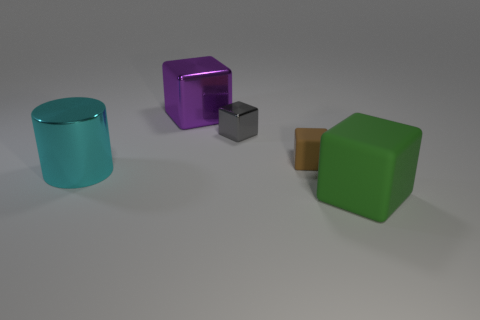Subtract all tiny brown matte cubes. How many cubes are left? 3 Add 3 small gray metallic objects. How many objects exist? 8 Subtract 1 blocks. How many blocks are left? 3 Subtract all purple blocks. How many blocks are left? 3 Subtract all cylinders. How many objects are left? 4 Add 4 large cyan rubber blocks. How many large cyan rubber blocks exist? 4 Subtract 0 cyan spheres. How many objects are left? 5 Subtract all red cylinders. Subtract all purple balls. How many cylinders are left? 1 Subtract all purple cubes. Subtract all cubes. How many objects are left? 0 Add 5 tiny rubber cubes. How many tiny rubber cubes are left? 6 